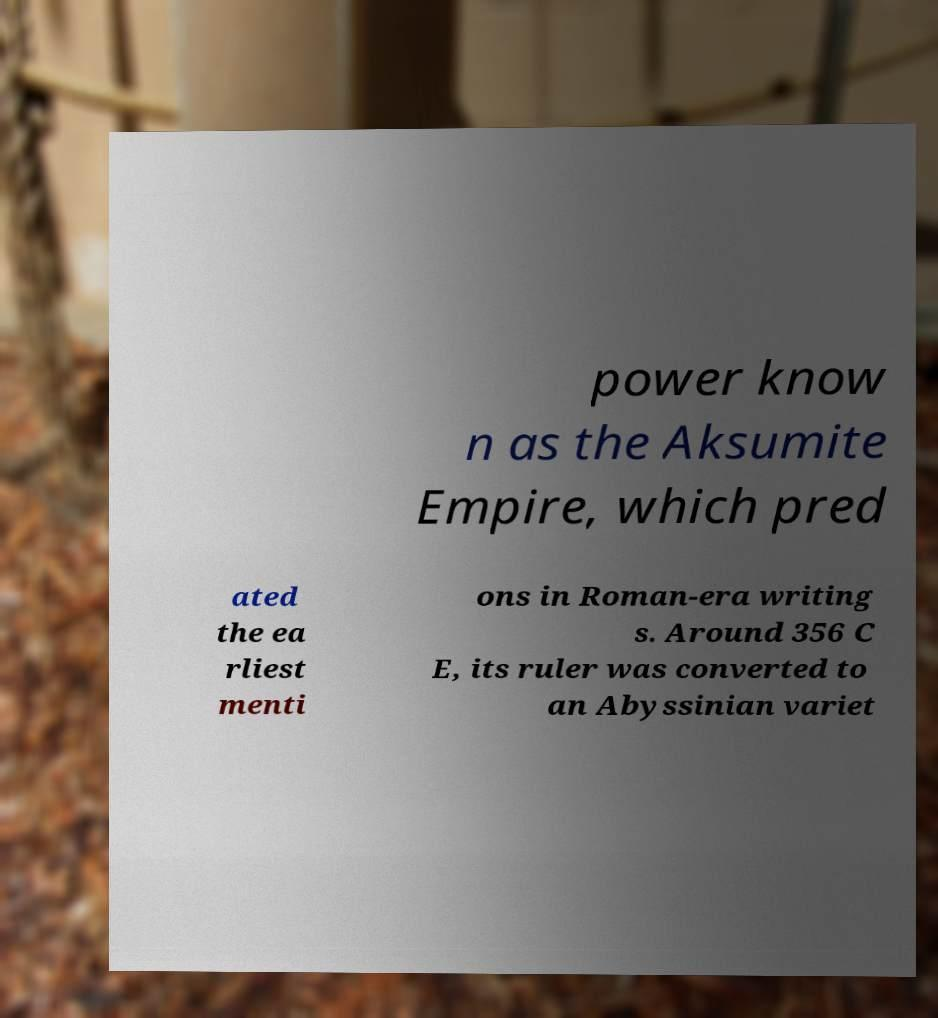I need the written content from this picture converted into text. Can you do that? power know n as the Aksumite Empire, which pred ated the ea rliest menti ons in Roman-era writing s. Around 356 C E, its ruler was converted to an Abyssinian variet 